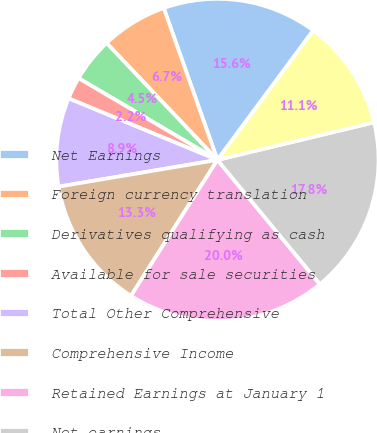Convert chart. <chart><loc_0><loc_0><loc_500><loc_500><pie_chart><fcel>Net Earnings<fcel>Foreign currency translation<fcel>Derivatives qualifying as cash<fcel>Available for sale securities<fcel>Total Other Comprehensive<fcel>Comprehensive Income<fcel>Retained Earnings at January 1<fcel>Net earnings<fcel>Cash dividends declared<nl><fcel>15.55%<fcel>6.67%<fcel>4.45%<fcel>2.23%<fcel>8.89%<fcel>13.33%<fcel>19.99%<fcel>17.77%<fcel>11.11%<nl></chart> 